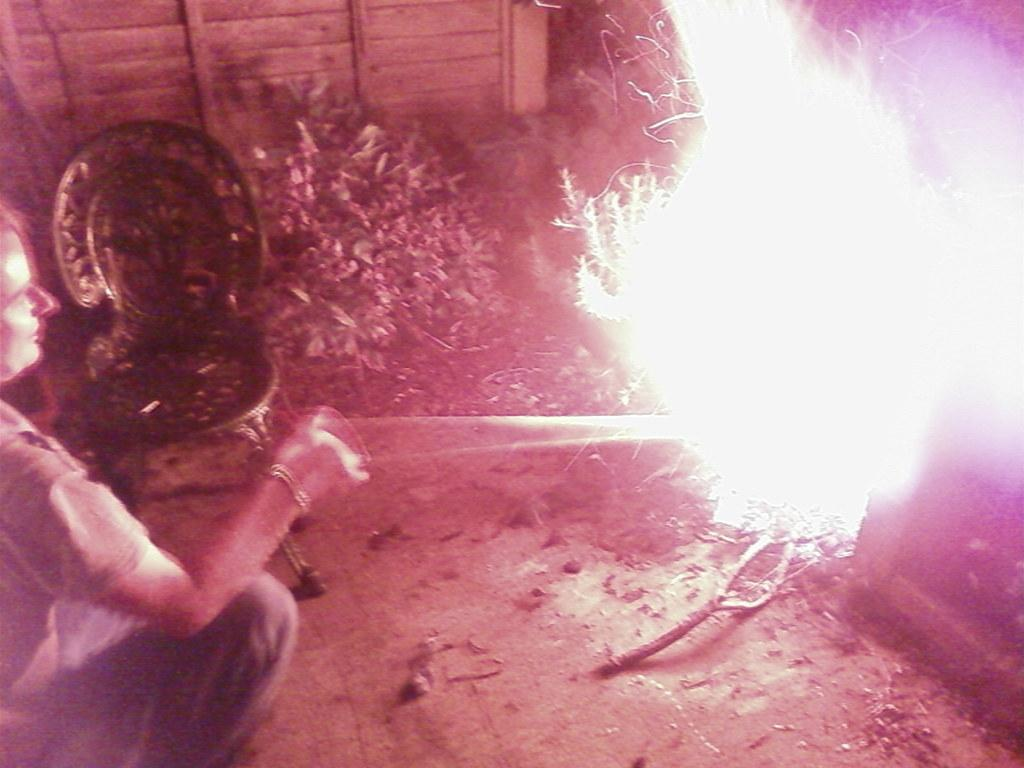Who or what is present in the image? There is a person in the image. What is the person wearing? The person is wearing a dress. What can be seen in the background of the image? There is a fire and plants visible in the image. What type of furniture is in the image? There is a chair in the image. What material is used for the wooden object in the image? The wooden object in the image is made of wood. What type of toy can be seen in the hands of the person in the image? There is no toy visible in the image; the person is not holding anything. 